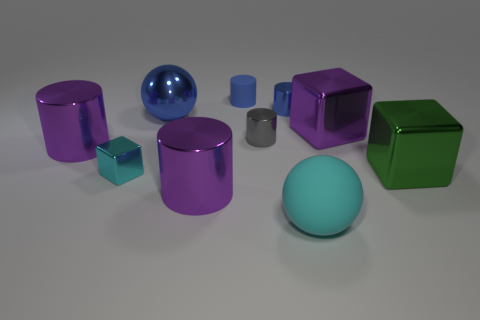What number of blue objects are to the left of the gray shiny object and to the right of the blue matte thing?
Offer a terse response. 0. What number of objects are tiny gray metal things or purple things that are left of the tiny cyan metal cube?
Keep it short and to the point. 2. The tiny object that is the same color as the small matte cylinder is what shape?
Offer a very short reply. Cylinder. What color is the ball behind the large cyan matte object?
Your response must be concise. Blue. How many things are either spheres that are behind the green metal cube or big shiny balls?
Make the answer very short. 1. What color is the matte thing that is the same size as the cyan metallic block?
Make the answer very short. Blue. Is the number of small blue cylinders on the right side of the big green metal block greater than the number of purple matte things?
Offer a terse response. No. There is a cube that is to the right of the small blue rubber cylinder and in front of the tiny gray cylinder; what material is it?
Your answer should be compact. Metal. Does the matte object that is in front of the matte cylinder have the same color as the small object in front of the green thing?
Your answer should be very brief. Yes. What number of other things are the same size as the cyan ball?
Ensure brevity in your answer.  5. 